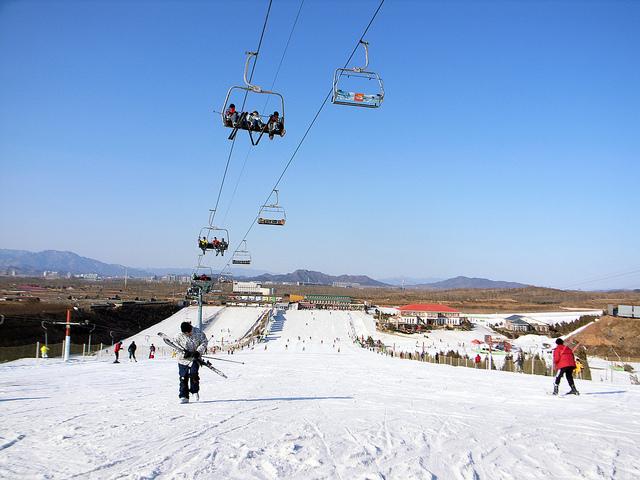Are there any fences?
Short answer required. Yes. What number of mountains are in the distance?
Keep it brief. 3. Which side of the ski lift is going up?
Answer briefly. Left. How many people are on the ski lift?
Keep it brief. 9. 